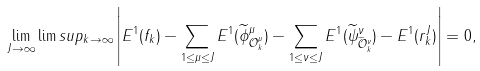Convert formula to latex. <formula><loc_0><loc_0><loc_500><loc_500>\lim _ { J \to \infty } \lim s u p _ { k \to \infty } \left | E ^ { 1 } ( f _ { k } ) - \sum _ { 1 \leq \mu \leq J } E ^ { 1 } ( \widetilde { \phi } ^ { \mu } _ { \mathcal { O } ^ { \mu } _ { k } } ) - \sum _ { 1 \leq \nu \leq J } E ^ { 1 } ( \widetilde { \psi } ^ { \nu } _ { \widetilde { \mathcal { O } } ^ { \nu } _ { k } } ) - E ^ { 1 } ( r _ { k } ^ { J } ) \right | = 0 ,</formula> 